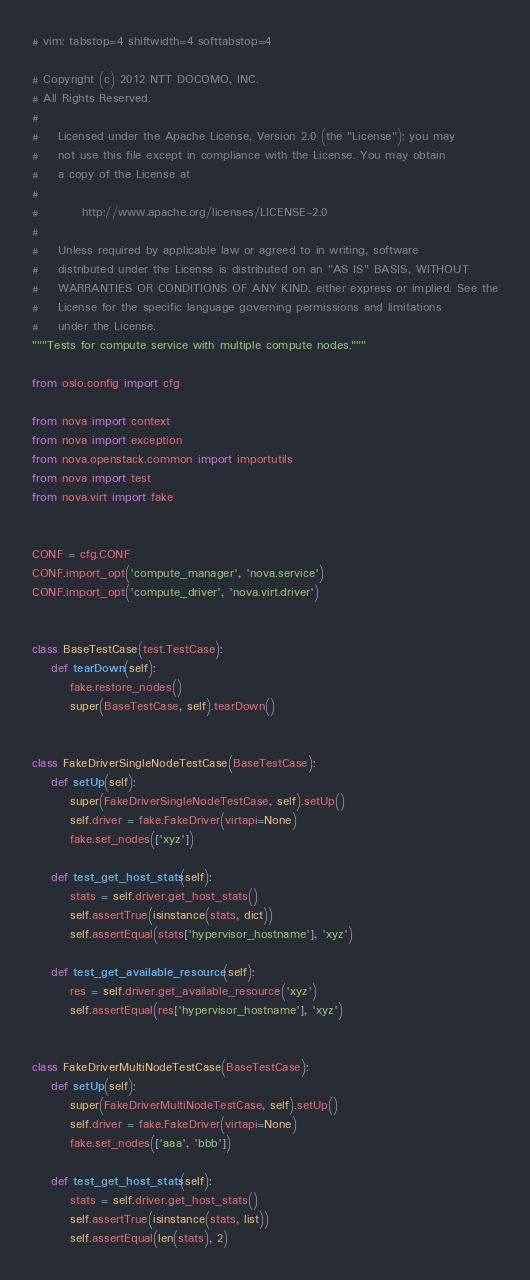Convert code to text. <code><loc_0><loc_0><loc_500><loc_500><_Python_># vim: tabstop=4 shiftwidth=4 softtabstop=4

# Copyright (c) 2012 NTT DOCOMO, INC.
# All Rights Reserved.
#
#    Licensed under the Apache License, Version 2.0 (the "License"); you may
#    not use this file except in compliance with the License. You may obtain
#    a copy of the License at
#
#         http://www.apache.org/licenses/LICENSE-2.0
#
#    Unless required by applicable law or agreed to in writing, software
#    distributed under the License is distributed on an "AS IS" BASIS, WITHOUT
#    WARRANTIES OR CONDITIONS OF ANY KIND, either express or implied. See the
#    License for the specific language governing permissions and limitations
#    under the License.
"""Tests for compute service with multiple compute nodes."""

from oslo.config import cfg

from nova import context
from nova import exception
from nova.openstack.common import importutils
from nova import test
from nova.virt import fake


CONF = cfg.CONF
CONF.import_opt('compute_manager', 'nova.service')
CONF.import_opt('compute_driver', 'nova.virt.driver')


class BaseTestCase(test.TestCase):
    def tearDown(self):
        fake.restore_nodes()
        super(BaseTestCase, self).tearDown()


class FakeDriverSingleNodeTestCase(BaseTestCase):
    def setUp(self):
        super(FakeDriverSingleNodeTestCase, self).setUp()
        self.driver = fake.FakeDriver(virtapi=None)
        fake.set_nodes(['xyz'])

    def test_get_host_stats(self):
        stats = self.driver.get_host_stats()
        self.assertTrue(isinstance(stats, dict))
        self.assertEqual(stats['hypervisor_hostname'], 'xyz')

    def test_get_available_resource(self):
        res = self.driver.get_available_resource('xyz')
        self.assertEqual(res['hypervisor_hostname'], 'xyz')


class FakeDriverMultiNodeTestCase(BaseTestCase):
    def setUp(self):
        super(FakeDriverMultiNodeTestCase, self).setUp()
        self.driver = fake.FakeDriver(virtapi=None)
        fake.set_nodes(['aaa', 'bbb'])

    def test_get_host_stats(self):
        stats = self.driver.get_host_stats()
        self.assertTrue(isinstance(stats, list))
        self.assertEqual(len(stats), 2)</code> 